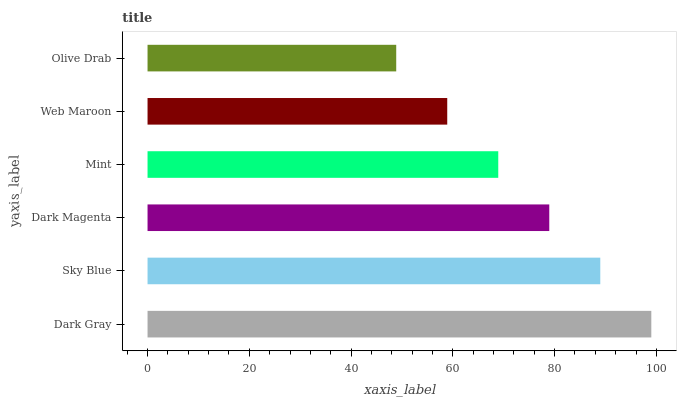Is Olive Drab the minimum?
Answer yes or no. Yes. Is Dark Gray the maximum?
Answer yes or no. Yes. Is Sky Blue the minimum?
Answer yes or no. No. Is Sky Blue the maximum?
Answer yes or no. No. Is Dark Gray greater than Sky Blue?
Answer yes or no. Yes. Is Sky Blue less than Dark Gray?
Answer yes or no. Yes. Is Sky Blue greater than Dark Gray?
Answer yes or no. No. Is Dark Gray less than Sky Blue?
Answer yes or no. No. Is Dark Magenta the high median?
Answer yes or no. Yes. Is Mint the low median?
Answer yes or no. Yes. Is Olive Drab the high median?
Answer yes or no. No. Is Dark Magenta the low median?
Answer yes or no. No. 